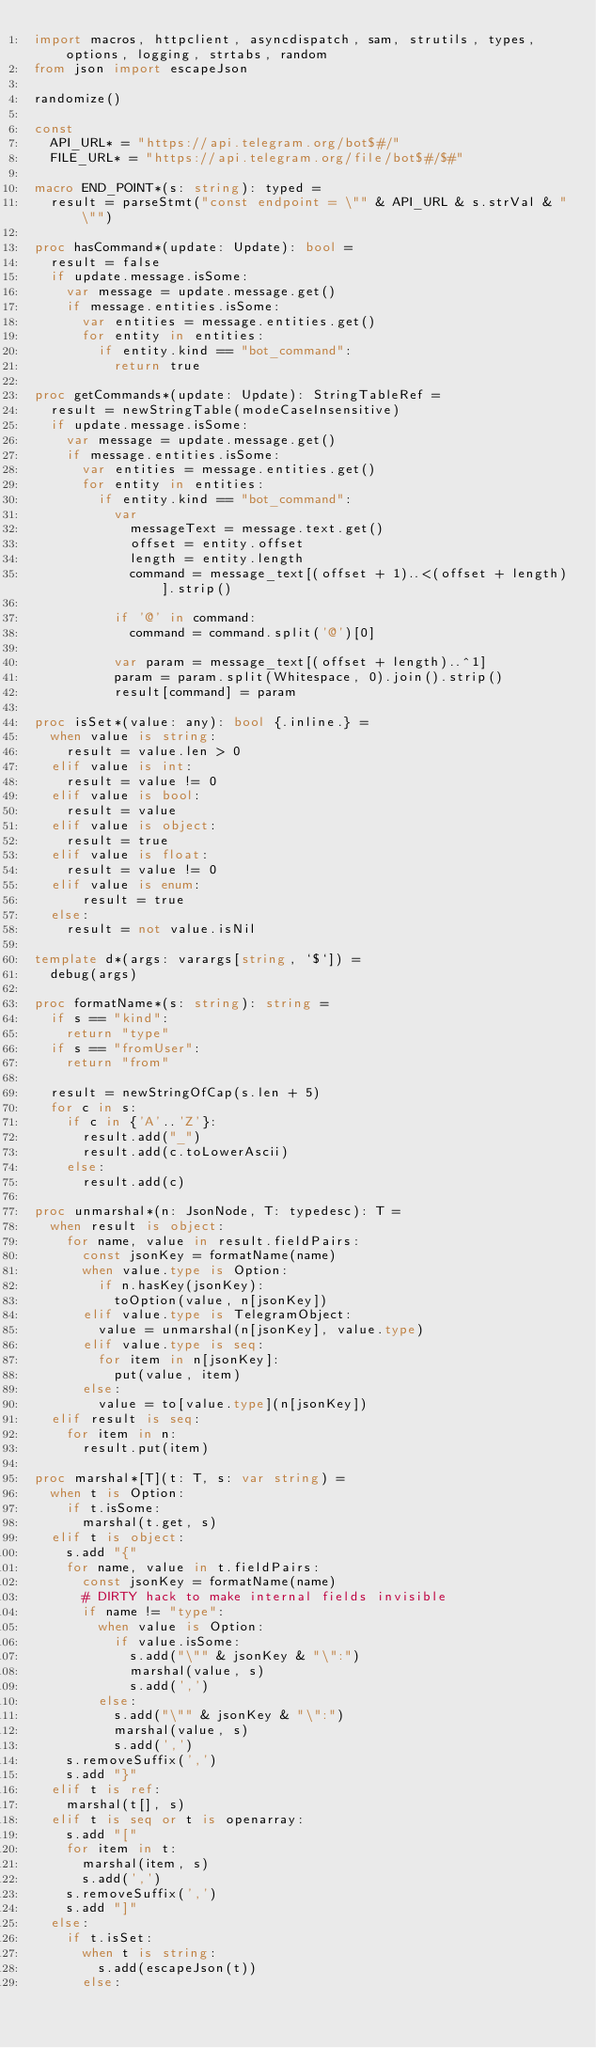<code> <loc_0><loc_0><loc_500><loc_500><_Nim_>import macros, httpclient, asyncdispatch, sam, strutils, types, options, logging, strtabs, random
from json import escapeJson

randomize()

const
  API_URL* = "https://api.telegram.org/bot$#/"
  FILE_URL* = "https://api.telegram.org/file/bot$#/$#"

macro END_POINT*(s: string): typed =
  result = parseStmt("const endpoint = \"" & API_URL & s.strVal & "\"")

proc hasCommand*(update: Update): bool =
  result = false
  if update.message.isSome:
    var message = update.message.get()
    if message.entities.isSome:
      var entities = message.entities.get()
      for entity in entities:
        if entity.kind == "bot_command":
          return true

proc getCommands*(update: Update): StringTableRef =
  result = newStringTable(modeCaseInsensitive)
  if update.message.isSome:
    var message = update.message.get()
    if message.entities.isSome:
      var entities = message.entities.get()
      for entity in entities:
        if entity.kind == "bot_command":
          var
            messageText = message.text.get()
            offset = entity.offset
            length = entity.length
            command = message_text[(offset + 1)..<(offset + length)].strip()

          if '@' in command:
            command = command.split('@')[0]

          var param = message_text[(offset + length)..^1]
          param = param.split(Whitespace, 0).join().strip()
          result[command] = param

proc isSet*(value: any): bool {.inline.} =
  when value is string:
    result = value.len > 0
  elif value is int:
    result = value != 0
  elif value is bool:
    result = value
  elif value is object:
    result = true
  elif value is float:
    result = value != 0
  elif value is enum:
      result = true
  else:
    result = not value.isNil

template d*(args: varargs[string, `$`]) =
  debug(args)

proc formatName*(s: string): string =
  if s == "kind":
    return "type"
  if s == "fromUser":
    return "from"

  result = newStringOfCap(s.len + 5)
  for c in s:
    if c in {'A'..'Z'}:
      result.add("_")
      result.add(c.toLowerAscii)
    else:
      result.add(c)

proc unmarshal*(n: JsonNode, T: typedesc): T =
  when result is object:
    for name, value in result.fieldPairs:
      const jsonKey = formatName(name)
      when value.type is Option:
        if n.hasKey(jsonKey):
          toOption(value, n[jsonKey])
      elif value.type is TelegramObject:
        value = unmarshal(n[jsonKey], value.type)
      elif value.type is seq:
        for item in n[jsonKey]:
          put(value, item)
      else:
        value = to[value.type](n[jsonKey])
  elif result is seq:
    for item in n:
      result.put(item)

proc marshal*[T](t: T, s: var string) =
  when t is Option:
    if t.isSome:
      marshal(t.get, s)
  elif t is object:
    s.add "{"
    for name, value in t.fieldPairs:
      const jsonKey = formatName(name)
      # DIRTY hack to make internal fields invisible
      if name != "type":
        when value is Option:
          if value.isSome:
            s.add("\"" & jsonKey & "\":")
            marshal(value, s)
            s.add(',')
        else:
          s.add("\"" & jsonKey & "\":")
          marshal(value, s)
          s.add(',')
    s.removeSuffix(',')
    s.add "}"
  elif t is ref:
    marshal(t[], s)
  elif t is seq or t is openarray:
    s.add "["
    for item in t:
      marshal(item, s)
      s.add(',')
    s.removeSuffix(',')
    s.add "]"
  else:
    if t.isSet:
      when t is string:
        s.add(escapeJson(t))
      else:</code> 